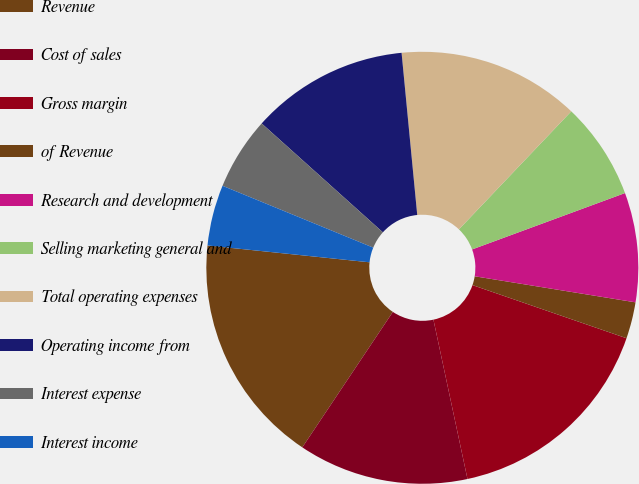<chart> <loc_0><loc_0><loc_500><loc_500><pie_chart><fcel>Revenue<fcel>Cost of sales<fcel>Gross margin<fcel>of Revenue<fcel>Research and development<fcel>Selling marketing general and<fcel>Total operating expenses<fcel>Operating income from<fcel>Interest expense<fcel>Interest income<nl><fcel>17.27%<fcel>12.73%<fcel>16.36%<fcel>2.73%<fcel>8.18%<fcel>7.27%<fcel>13.64%<fcel>11.82%<fcel>5.45%<fcel>4.55%<nl></chart> 